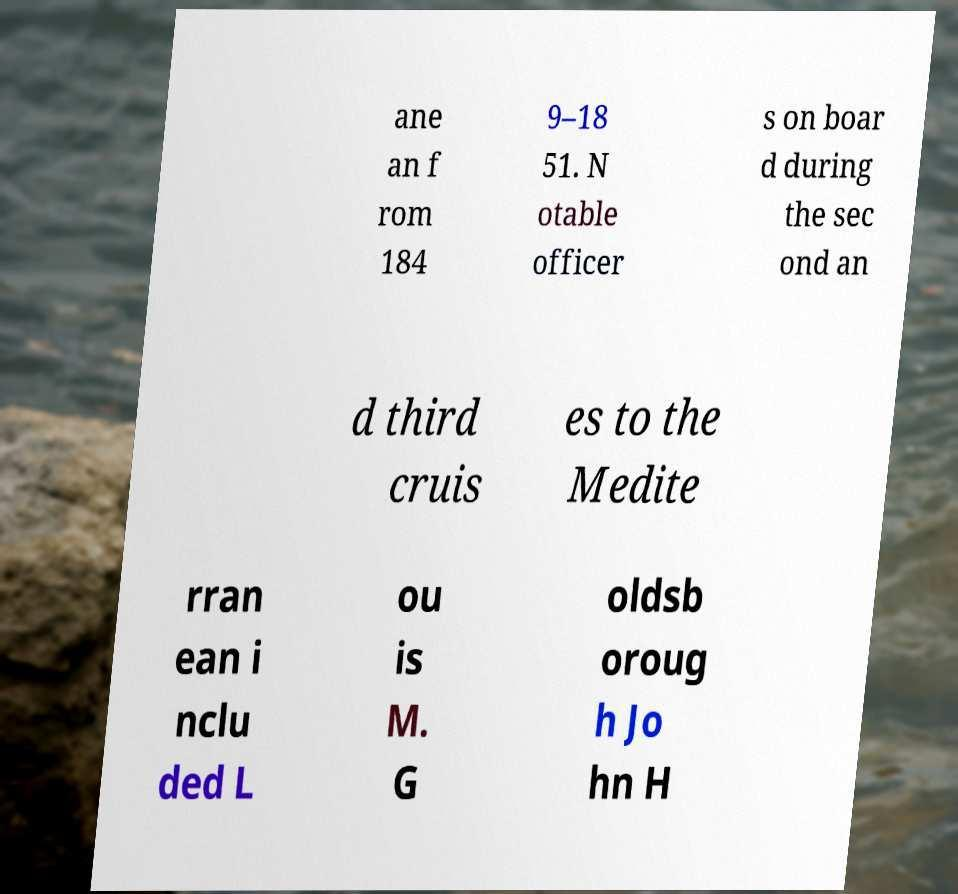Can you accurately transcribe the text from the provided image for me? ane an f rom 184 9–18 51. N otable officer s on boar d during the sec ond an d third cruis es to the Medite rran ean i nclu ded L ou is M. G oldsb oroug h Jo hn H 